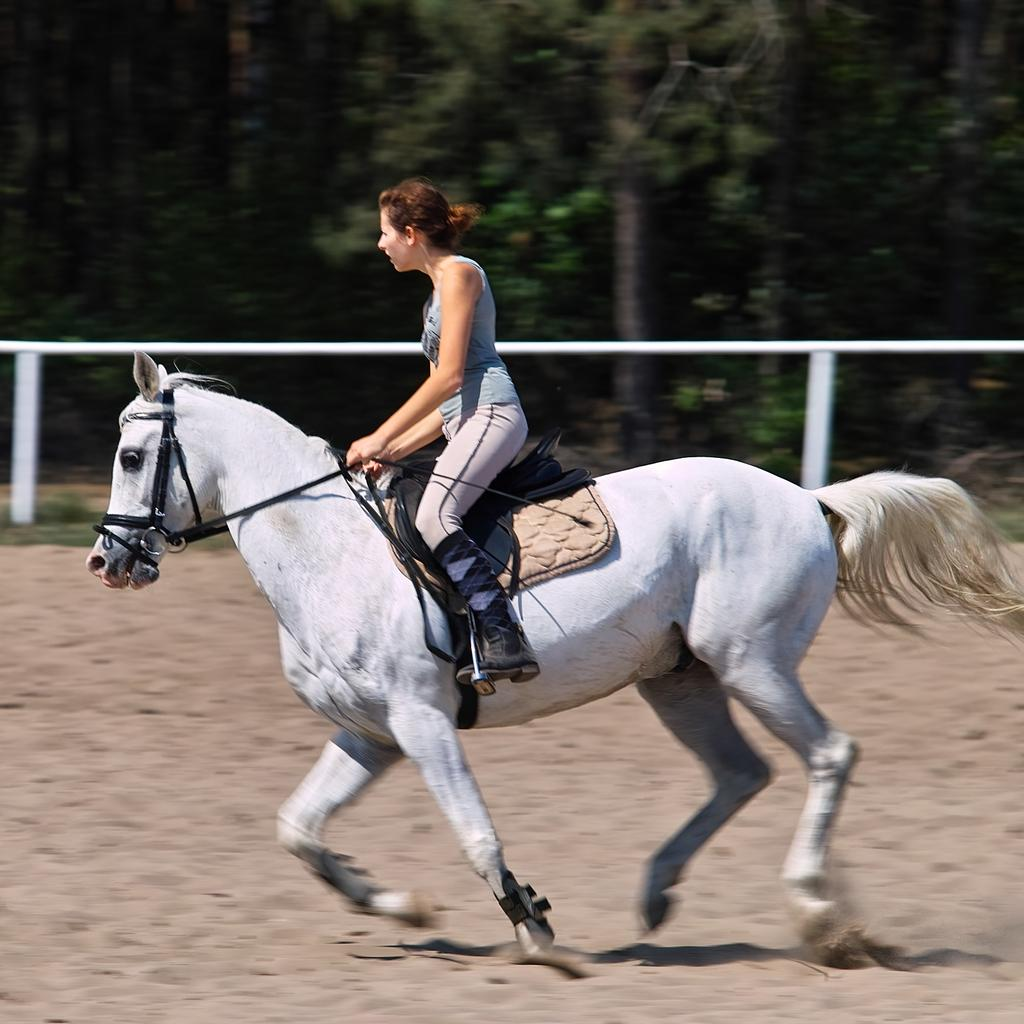Who is the main subject in the image? There is a woman in the image. What is the woman doing in the image? The woman is on a horse. What is the horse doing in the image? The horse is running on the sand. What can be seen in the background of the image? There is fencing and trees in the image. What type of steam is coming out of the horse's ears in the image? There is no steam coming out of the horse's ears in the image; the horse is running on the sand without any visible steam. 